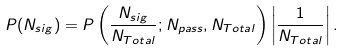Convert formula to latex. <formula><loc_0><loc_0><loc_500><loc_500>P ( N _ { s i g } ) = P \left ( \frac { N _ { s i g } } { N _ { T o t a l } } ; N _ { p a s s } , N _ { T o t a l } \right ) \left | \frac { 1 } { N _ { T o t a l } } \right | .</formula> 